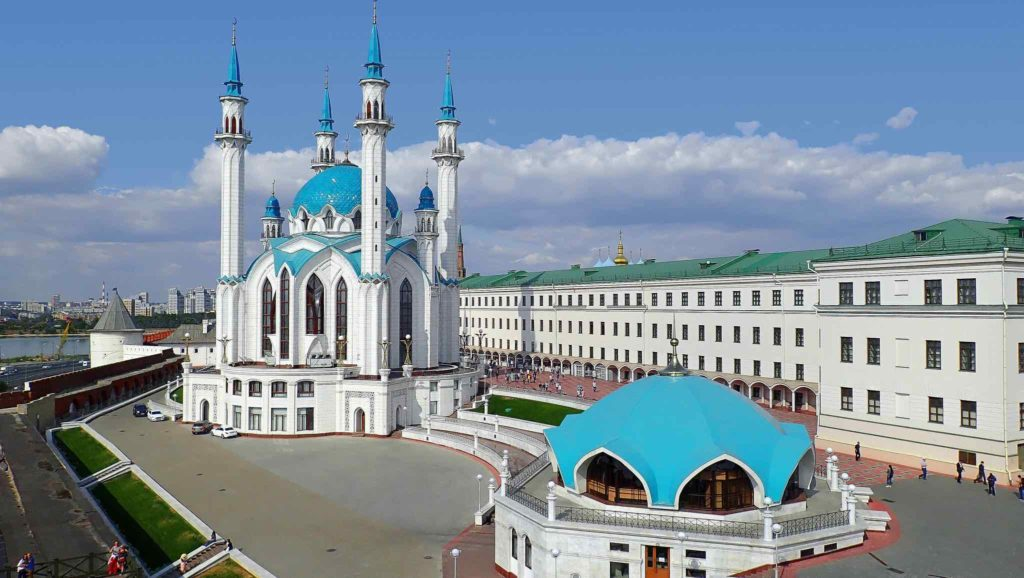What historical events are associated with the Kazan Kremlin? The Kazan Kremlin is a site of profound historical significance. It was a critical location in the expansion of the Russian Empire after its capture from the Khanate of Kazan in 1552, cementing Tsar Ivan the Terrible's influence over the region. This event marked a pivotal moment in the integration of the Tatar people and their culture into the Russian state. Over the centuries, it has served various administrative and military functions and has been a symbol of political authority in the region. Today, it stands as a UNESCO World Heritage Site, recognized for its historical and cultural importance. 